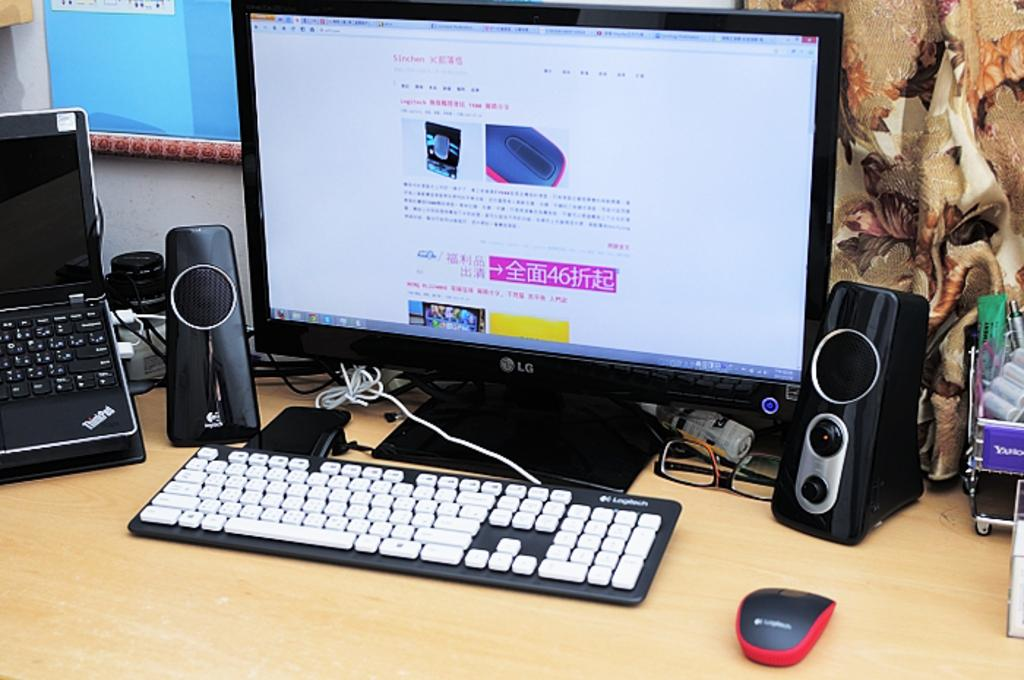<image>
Render a clear and concise summary of the photo. An LG computer with some foreign writing on it 